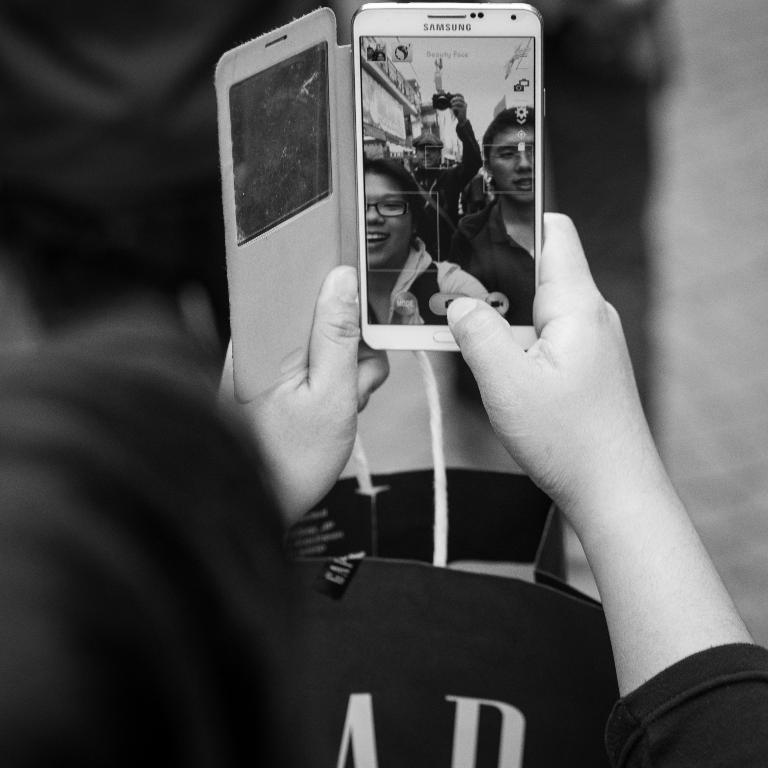<image>
Share a concise interpretation of the image provided. A woman looks at pictures on her white Samsung phone. 